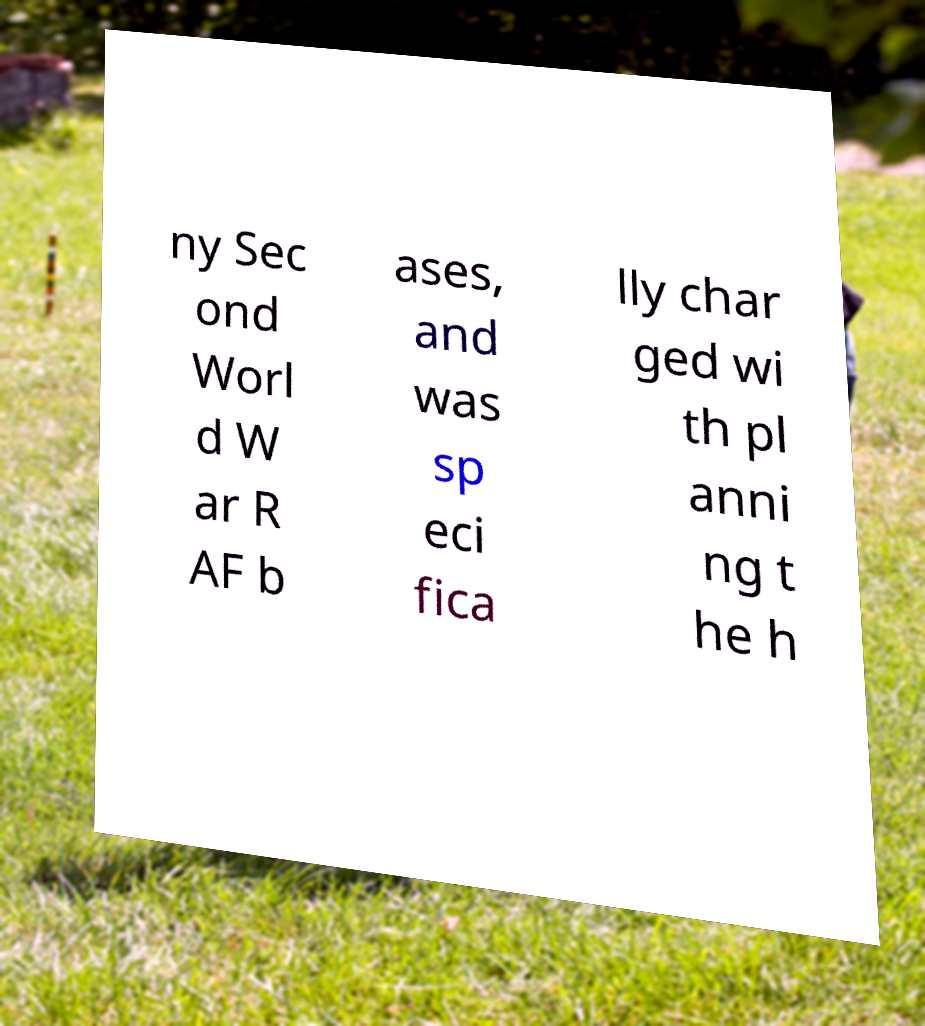For documentation purposes, I need the text within this image transcribed. Could you provide that? ny Sec ond Worl d W ar R AF b ases, and was sp eci fica lly char ged wi th pl anni ng t he h 